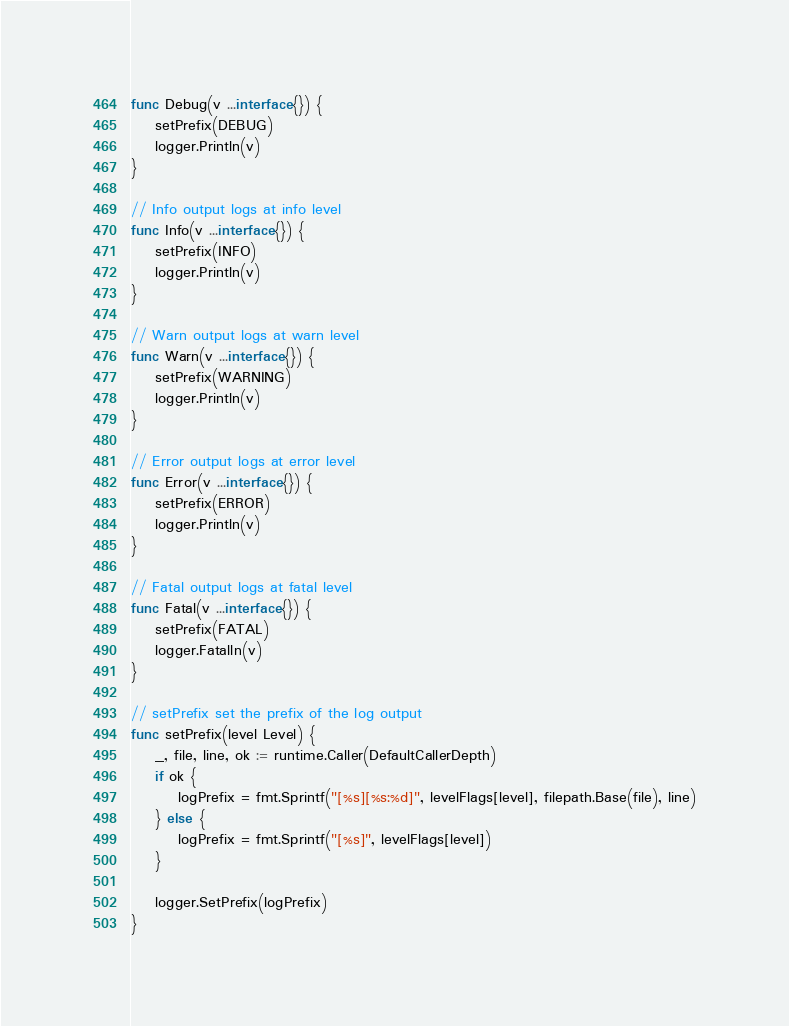<code> <loc_0><loc_0><loc_500><loc_500><_Go_>func Debug(v ...interface{}) {
	setPrefix(DEBUG)
	logger.Println(v)
}

// Info output logs at info level
func Info(v ...interface{}) {
	setPrefix(INFO)
	logger.Println(v)
}

// Warn output logs at warn level
func Warn(v ...interface{}) {
	setPrefix(WARNING)
	logger.Println(v)
}

// Error output logs at error level
func Error(v ...interface{}) {
	setPrefix(ERROR)
	logger.Println(v)
}

// Fatal output logs at fatal level
func Fatal(v ...interface{}) {
	setPrefix(FATAL)
	logger.Fatalln(v)
}

// setPrefix set the prefix of the log output
func setPrefix(level Level) {
	_, file, line, ok := runtime.Caller(DefaultCallerDepth)
	if ok {
		logPrefix = fmt.Sprintf("[%s][%s:%d]", levelFlags[level], filepath.Base(file), line)
	} else {
		logPrefix = fmt.Sprintf("[%s]", levelFlags[level])
	}

	logger.SetPrefix(logPrefix)
}
</code> 